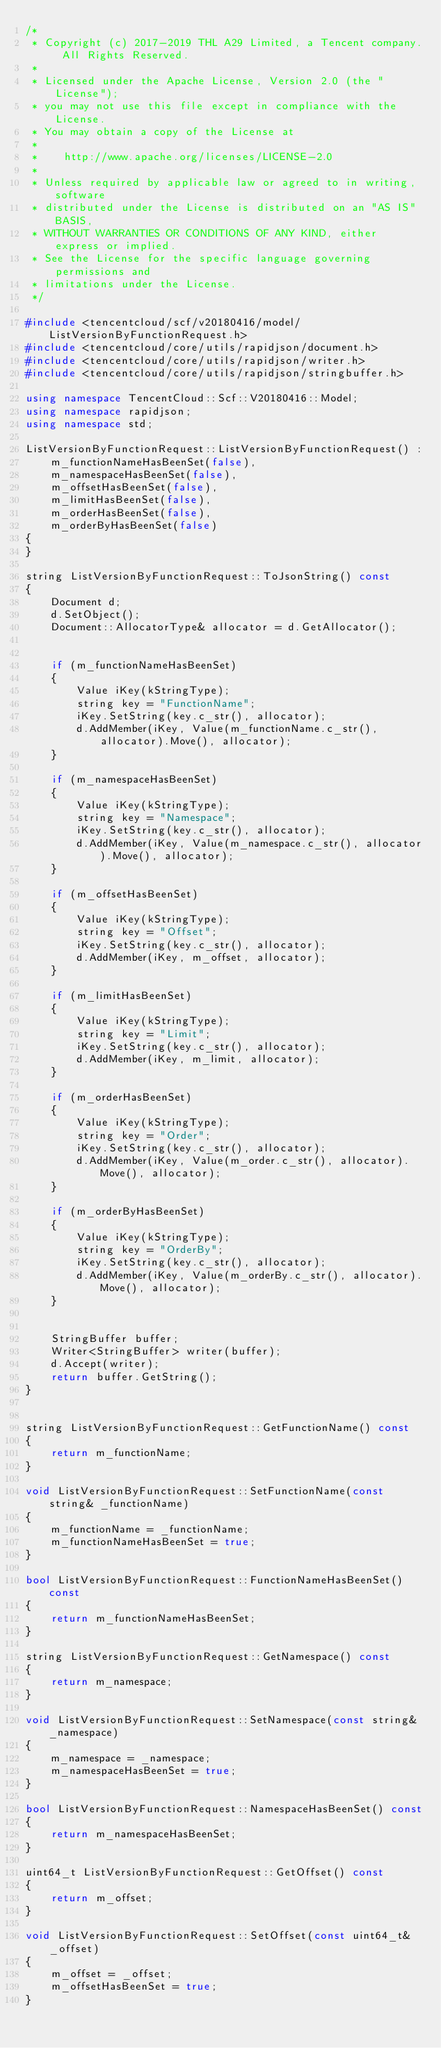Convert code to text. <code><loc_0><loc_0><loc_500><loc_500><_C++_>/*
 * Copyright (c) 2017-2019 THL A29 Limited, a Tencent company. All Rights Reserved.
 *
 * Licensed under the Apache License, Version 2.0 (the "License");
 * you may not use this file except in compliance with the License.
 * You may obtain a copy of the License at
 *
 *    http://www.apache.org/licenses/LICENSE-2.0
 *
 * Unless required by applicable law or agreed to in writing, software
 * distributed under the License is distributed on an "AS IS" BASIS,
 * WITHOUT WARRANTIES OR CONDITIONS OF ANY KIND, either express or implied.
 * See the License for the specific language governing permissions and
 * limitations under the License.
 */

#include <tencentcloud/scf/v20180416/model/ListVersionByFunctionRequest.h>
#include <tencentcloud/core/utils/rapidjson/document.h>
#include <tencentcloud/core/utils/rapidjson/writer.h>
#include <tencentcloud/core/utils/rapidjson/stringbuffer.h>

using namespace TencentCloud::Scf::V20180416::Model;
using namespace rapidjson;
using namespace std;

ListVersionByFunctionRequest::ListVersionByFunctionRequest() :
    m_functionNameHasBeenSet(false),
    m_namespaceHasBeenSet(false),
    m_offsetHasBeenSet(false),
    m_limitHasBeenSet(false),
    m_orderHasBeenSet(false),
    m_orderByHasBeenSet(false)
{
}

string ListVersionByFunctionRequest::ToJsonString() const
{
    Document d;
    d.SetObject();
    Document::AllocatorType& allocator = d.GetAllocator();


    if (m_functionNameHasBeenSet)
    {
        Value iKey(kStringType);
        string key = "FunctionName";
        iKey.SetString(key.c_str(), allocator);
        d.AddMember(iKey, Value(m_functionName.c_str(), allocator).Move(), allocator);
    }

    if (m_namespaceHasBeenSet)
    {
        Value iKey(kStringType);
        string key = "Namespace";
        iKey.SetString(key.c_str(), allocator);
        d.AddMember(iKey, Value(m_namespace.c_str(), allocator).Move(), allocator);
    }

    if (m_offsetHasBeenSet)
    {
        Value iKey(kStringType);
        string key = "Offset";
        iKey.SetString(key.c_str(), allocator);
        d.AddMember(iKey, m_offset, allocator);
    }

    if (m_limitHasBeenSet)
    {
        Value iKey(kStringType);
        string key = "Limit";
        iKey.SetString(key.c_str(), allocator);
        d.AddMember(iKey, m_limit, allocator);
    }

    if (m_orderHasBeenSet)
    {
        Value iKey(kStringType);
        string key = "Order";
        iKey.SetString(key.c_str(), allocator);
        d.AddMember(iKey, Value(m_order.c_str(), allocator).Move(), allocator);
    }

    if (m_orderByHasBeenSet)
    {
        Value iKey(kStringType);
        string key = "OrderBy";
        iKey.SetString(key.c_str(), allocator);
        d.AddMember(iKey, Value(m_orderBy.c_str(), allocator).Move(), allocator);
    }


    StringBuffer buffer;
    Writer<StringBuffer> writer(buffer);
    d.Accept(writer);
    return buffer.GetString();
}


string ListVersionByFunctionRequest::GetFunctionName() const
{
    return m_functionName;
}

void ListVersionByFunctionRequest::SetFunctionName(const string& _functionName)
{
    m_functionName = _functionName;
    m_functionNameHasBeenSet = true;
}

bool ListVersionByFunctionRequest::FunctionNameHasBeenSet() const
{
    return m_functionNameHasBeenSet;
}

string ListVersionByFunctionRequest::GetNamespace() const
{
    return m_namespace;
}

void ListVersionByFunctionRequest::SetNamespace(const string& _namespace)
{
    m_namespace = _namespace;
    m_namespaceHasBeenSet = true;
}

bool ListVersionByFunctionRequest::NamespaceHasBeenSet() const
{
    return m_namespaceHasBeenSet;
}

uint64_t ListVersionByFunctionRequest::GetOffset() const
{
    return m_offset;
}

void ListVersionByFunctionRequest::SetOffset(const uint64_t& _offset)
{
    m_offset = _offset;
    m_offsetHasBeenSet = true;
}
</code> 